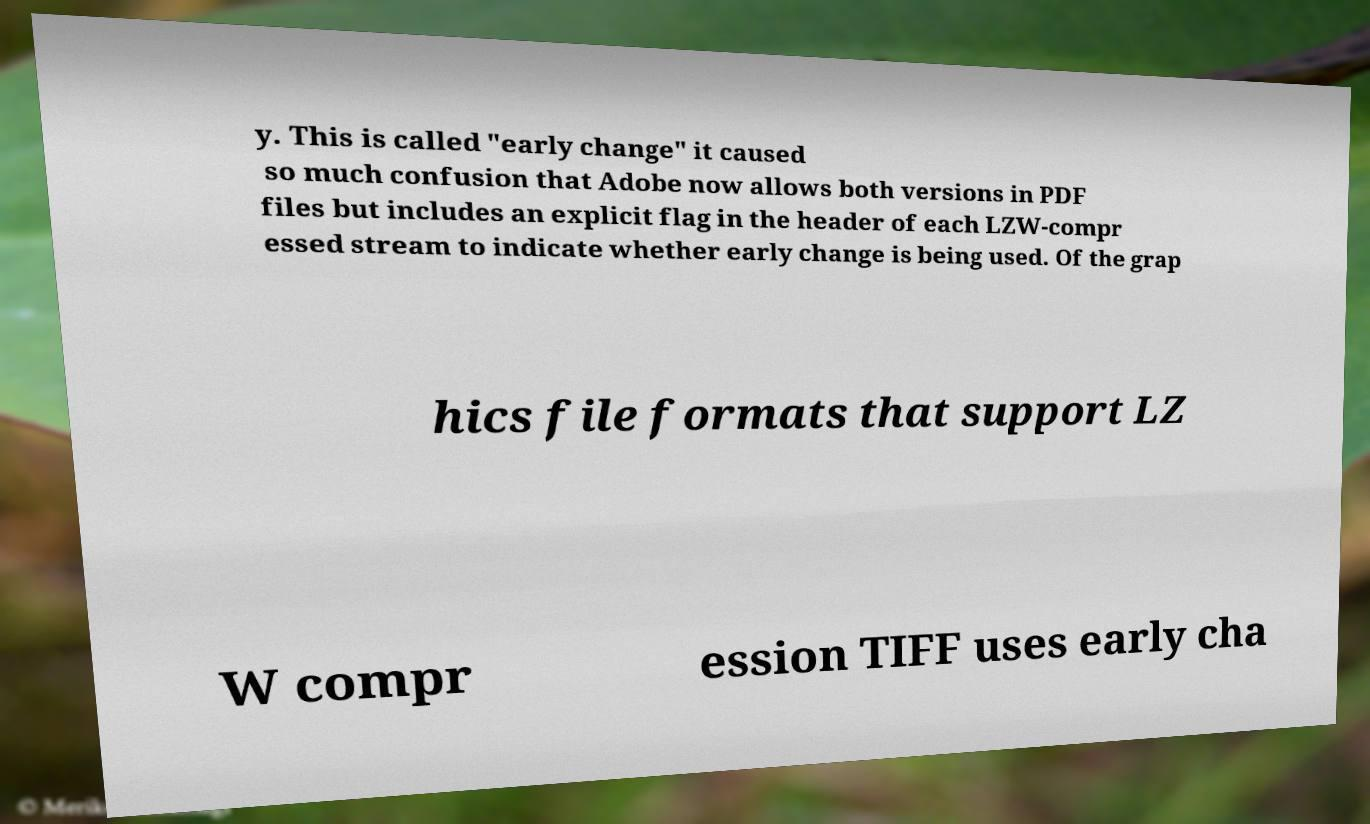Please identify and transcribe the text found in this image. y. This is called "early change" it caused so much confusion that Adobe now allows both versions in PDF files but includes an explicit flag in the header of each LZW-compr essed stream to indicate whether early change is being used. Of the grap hics file formats that support LZ W compr ession TIFF uses early cha 